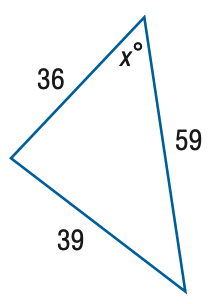Answer the mathemtical geometry problem and directly provide the correct option letter.
Question: Find x. Round the angle measure to the nearest degree.
Choices: A: 30 B: 35 C: 40 D: 45 C 